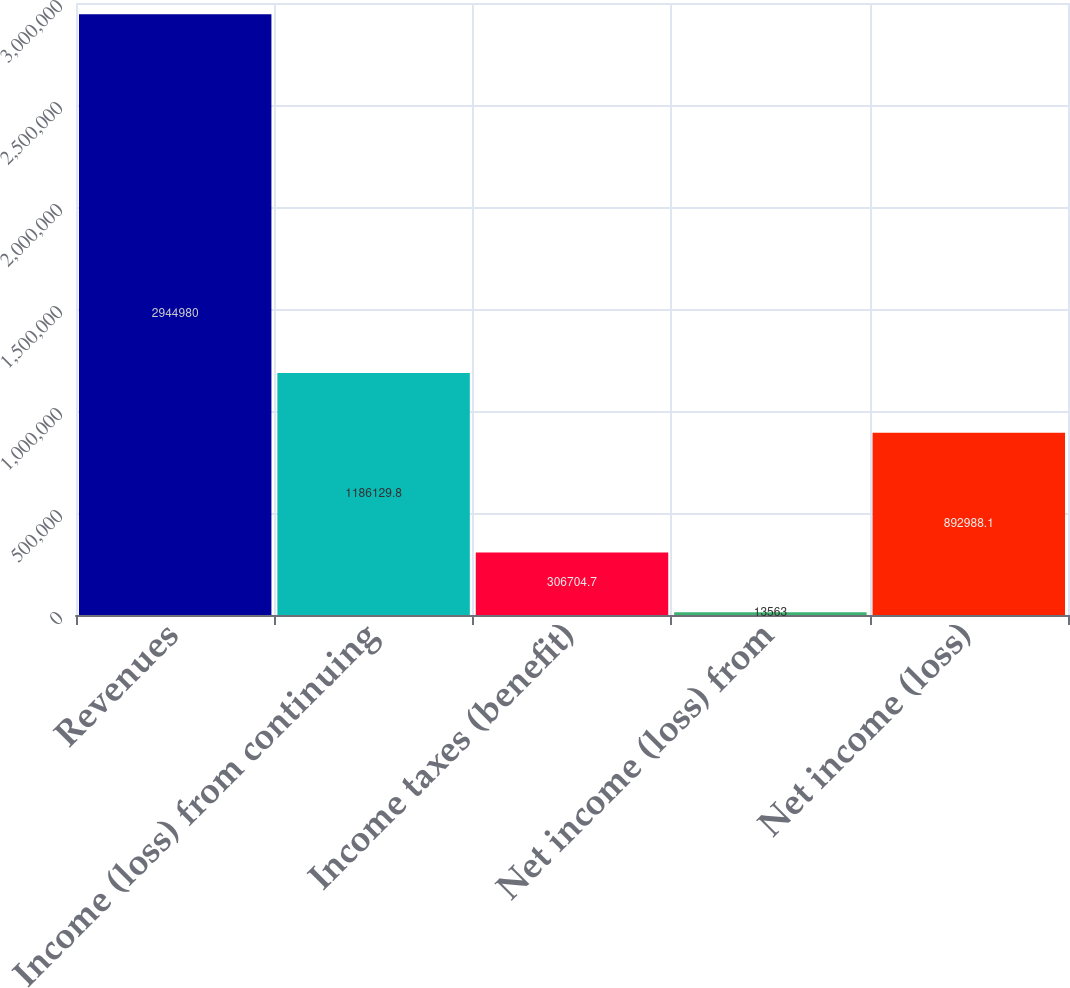<chart> <loc_0><loc_0><loc_500><loc_500><bar_chart><fcel>Revenues<fcel>Income (loss) from continuing<fcel>Income taxes (benefit)<fcel>Net income (loss) from<fcel>Net income (loss)<nl><fcel>2.94498e+06<fcel>1.18613e+06<fcel>306705<fcel>13563<fcel>892988<nl></chart> 